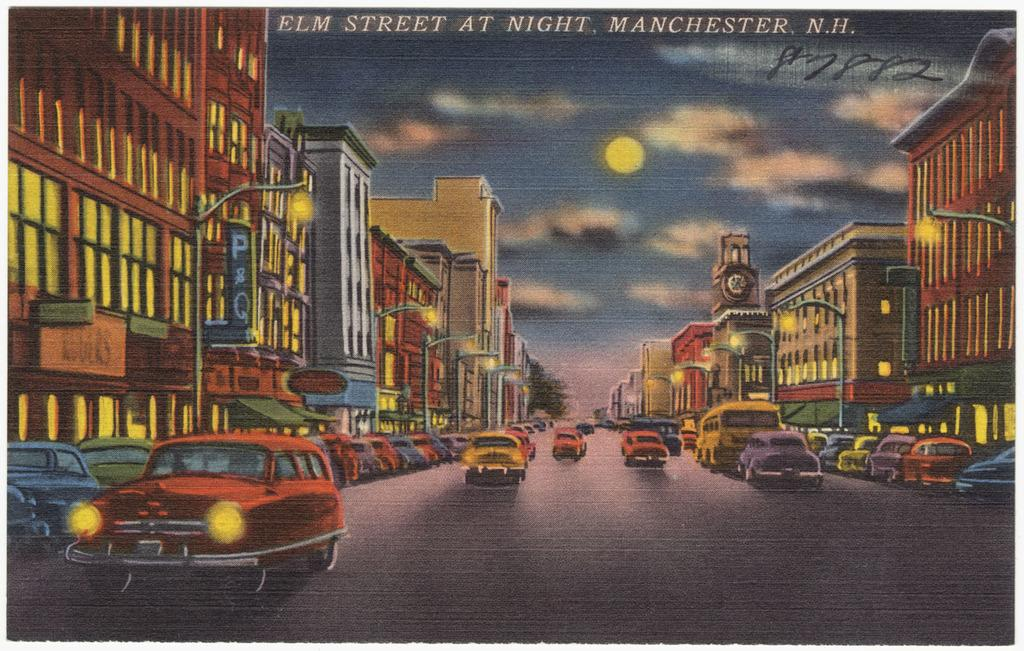<image>
Render a clear and concise summary of the photo. A picture of cars driving on the road and at the top it says Elm Street at Night in Manchester, N.H. 